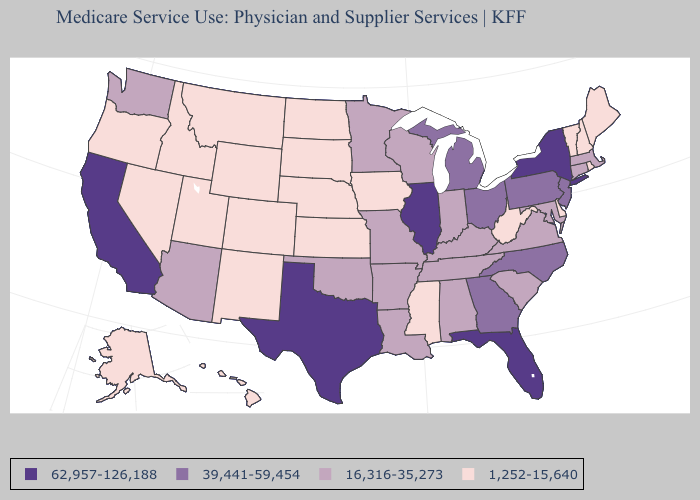Does Hawaii have the highest value in the West?
Keep it brief. No. Does Vermont have the same value as Hawaii?
Short answer required. Yes. What is the lowest value in the South?
Concise answer only. 1,252-15,640. Among the states that border Louisiana , does Mississippi have the highest value?
Be succinct. No. Name the states that have a value in the range 16,316-35,273?
Be succinct. Alabama, Arizona, Arkansas, Connecticut, Indiana, Kentucky, Louisiana, Maryland, Massachusetts, Minnesota, Missouri, Oklahoma, South Carolina, Tennessee, Virginia, Washington, Wisconsin. Which states have the lowest value in the West?
Give a very brief answer. Alaska, Colorado, Hawaii, Idaho, Montana, Nevada, New Mexico, Oregon, Utah, Wyoming. What is the value of Connecticut?
Quick response, please. 16,316-35,273. Does West Virginia have a higher value than Kansas?
Write a very short answer. No. Which states hav the highest value in the West?
Give a very brief answer. California. Among the states that border Illinois , does Iowa have the highest value?
Give a very brief answer. No. What is the value of South Carolina?
Short answer required. 16,316-35,273. Among the states that border Delaware , which have the highest value?
Keep it brief. New Jersey, Pennsylvania. Which states hav the highest value in the Northeast?
Answer briefly. New York. 